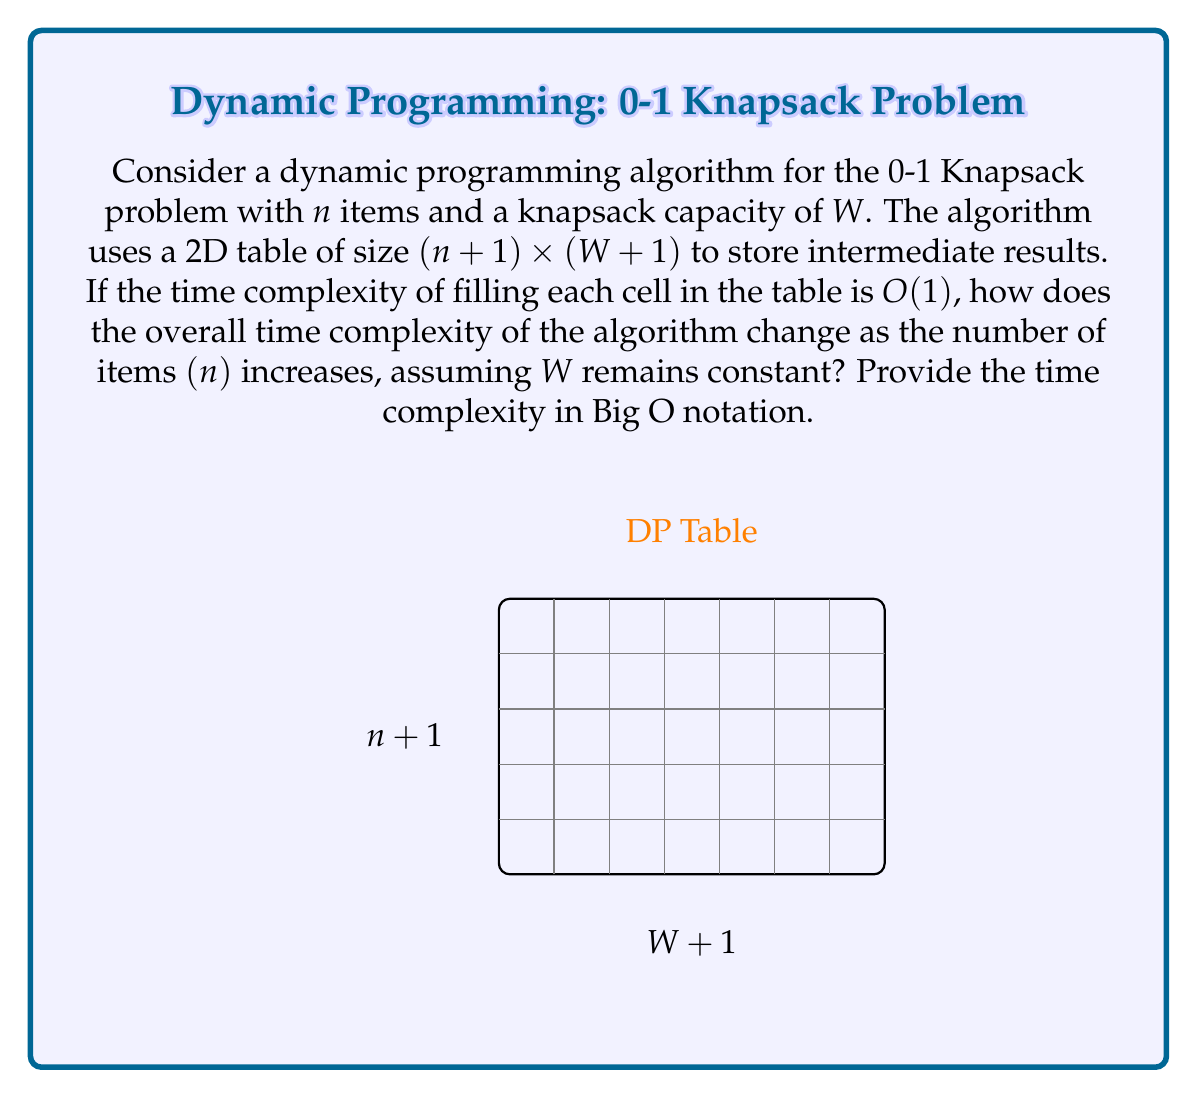Show me your answer to this math problem. Let's analyze this step-by-step:

1) The dynamic programming table has dimensions $(n+1) \times (W+1)$, where $n$ is the number of items and $W$ is the knapsack capacity.

2) The total number of cells in the table is $(n+1)(W+1)$.

3) We're told that filling each cell takes $O(1)$ time.

4) Therefore, the total time to fill the entire table is $O((n+1)(W+1))$.

5) We're asked to consider how the time complexity changes as $n$ increases, while $W$ remains constant.

6) When $W$ is constant, we can treat $(W+1)$ as a constant factor.

7) In Big O notation, we can drop constant factors and lower-order terms. So $(n+1)(W+1)$ simplifies to just $n$.

8) Thus, as $n$ increases with $W$ constant, the time complexity grows linearly with $n$.

This analysis shows that the algorithm's running time increases linearly with the number of items, which is characteristic of many dynamic programming solutions. It demonstrates the efficiency of the dynamic programming approach for the Knapsack problem, as it avoids the exponential time complexity of a naive recursive solution.
Answer: $O(n)$ 